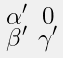Convert formula to latex. <formula><loc_0><loc_0><loc_500><loc_500>\begin{smallmatrix} \alpha ^ { \prime } & 0 \\ \beta ^ { \prime } & \gamma ^ { \prime } \end{smallmatrix}</formula> 